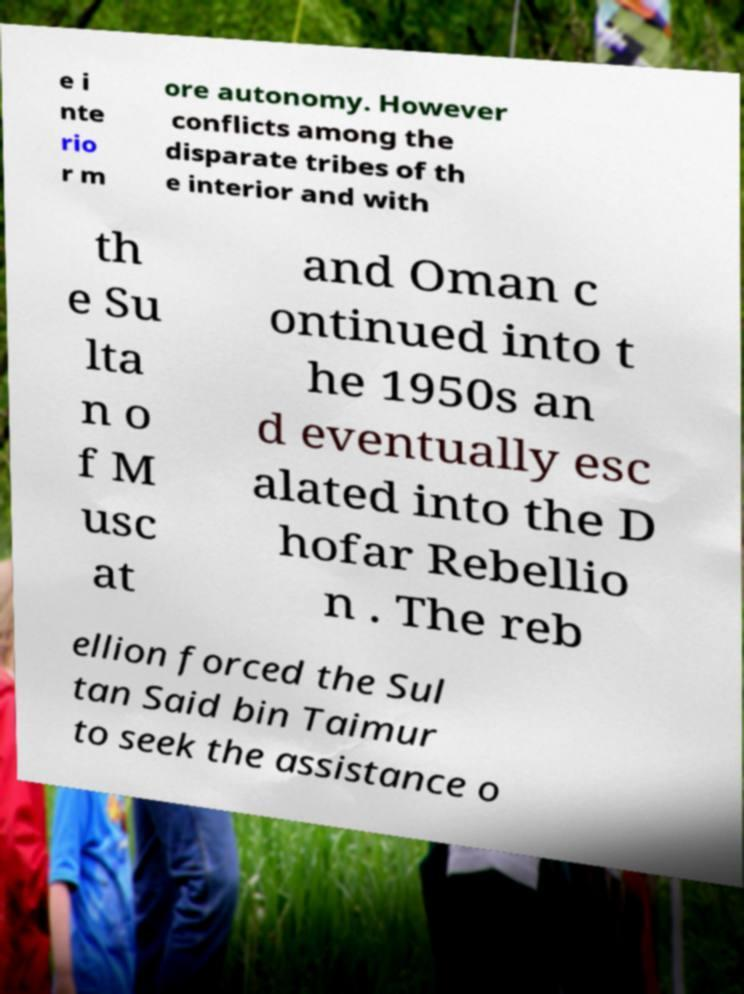There's text embedded in this image that I need extracted. Can you transcribe it verbatim? e i nte rio r m ore autonomy. However conflicts among the disparate tribes of th e interior and with th e Su lta n o f M usc at and Oman c ontinued into t he 1950s an d eventually esc alated into the D hofar Rebellio n . The reb ellion forced the Sul tan Said bin Taimur to seek the assistance o 